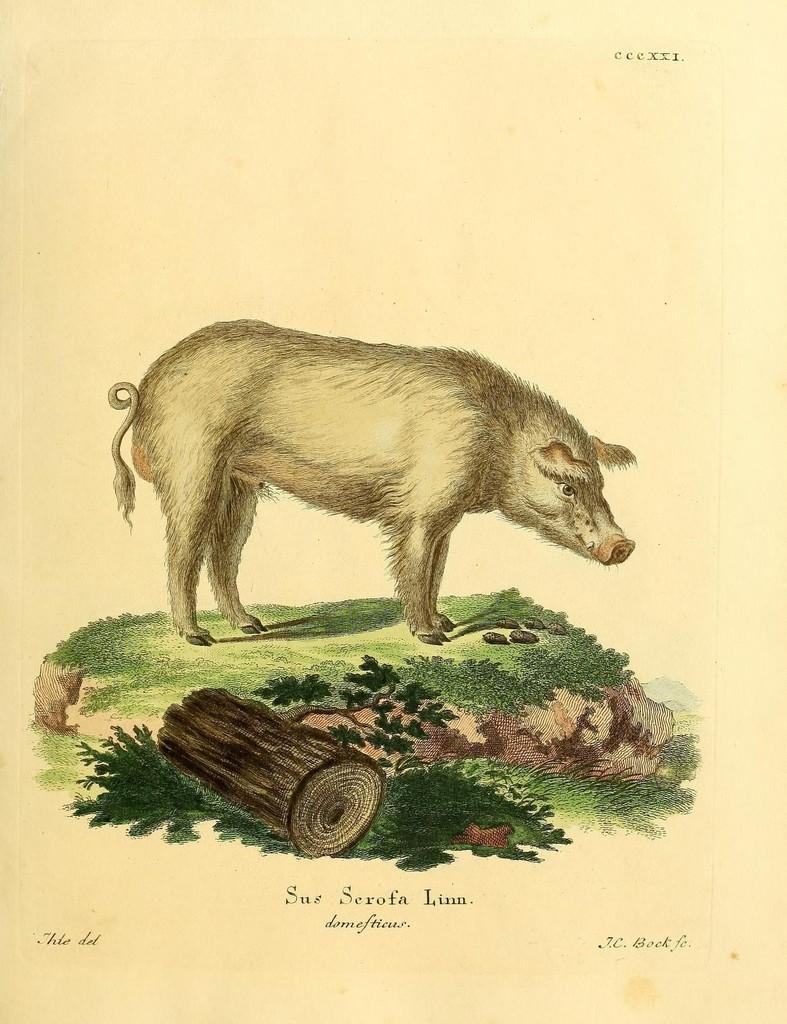What is depicted in the painting in the image? There is a painting of a pig in the image. What can be seen near the pig in the image? There is a wooden piece near the pig in the image. Are there any words or letters on the image? Yes, there is text or writing on the image. Can you see the foot of the artist who painted the pig in the image? There is no foot visible in the image, as it is a painting of a pig and not a photograph of the artist. 